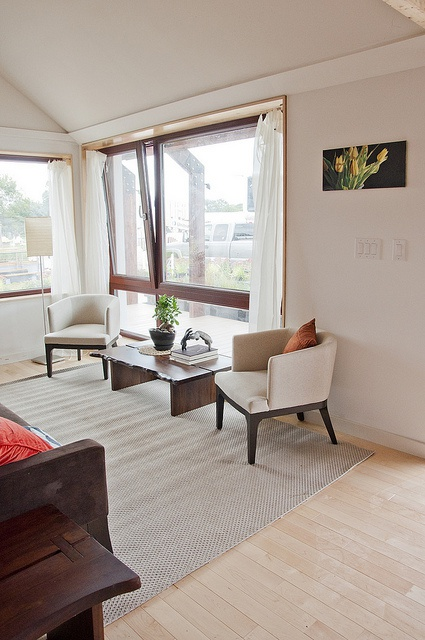Describe the objects in this image and their specific colors. I can see dining table in darkgray, black, maroon, and gray tones, chair in darkgray, gray, and black tones, couch in darkgray, black, gray, and salmon tones, chair in darkgray, lightgray, gray, and black tones, and potted plant in darkgray, black, white, and gray tones in this image. 